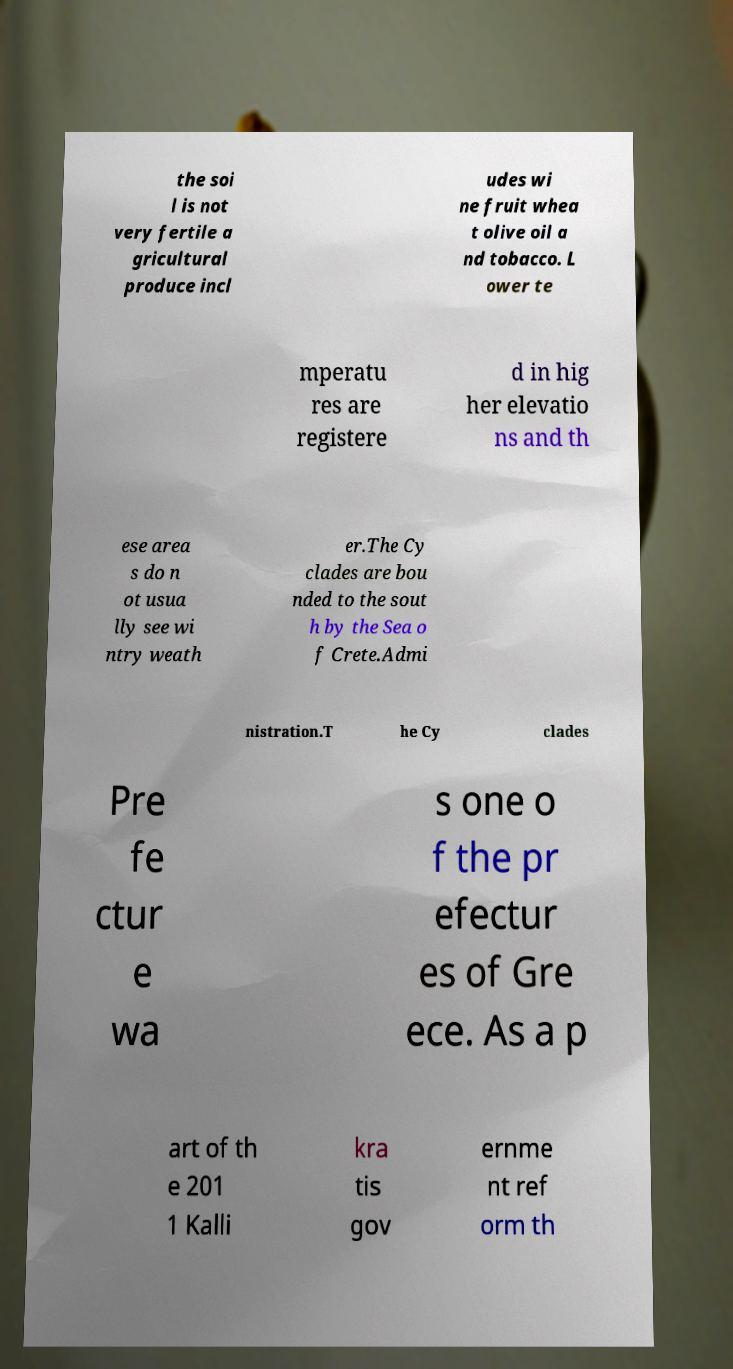Could you extract and type out the text from this image? the soi l is not very fertile a gricultural produce incl udes wi ne fruit whea t olive oil a nd tobacco. L ower te mperatu res are registere d in hig her elevatio ns and th ese area s do n ot usua lly see wi ntry weath er.The Cy clades are bou nded to the sout h by the Sea o f Crete.Admi nistration.T he Cy clades Pre fe ctur e wa s one o f the pr efectur es of Gre ece. As a p art of th e 201 1 Kalli kra tis gov ernme nt ref orm th 